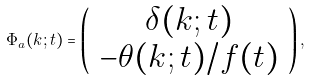<formula> <loc_0><loc_0><loc_500><loc_500>\Phi _ { a } ( k ; t ) = \left ( \begin{array} { c } \delta ( k ; t ) \\ - \theta ( k ; t ) / f ( t ) \end{array} \right ) ,</formula> 